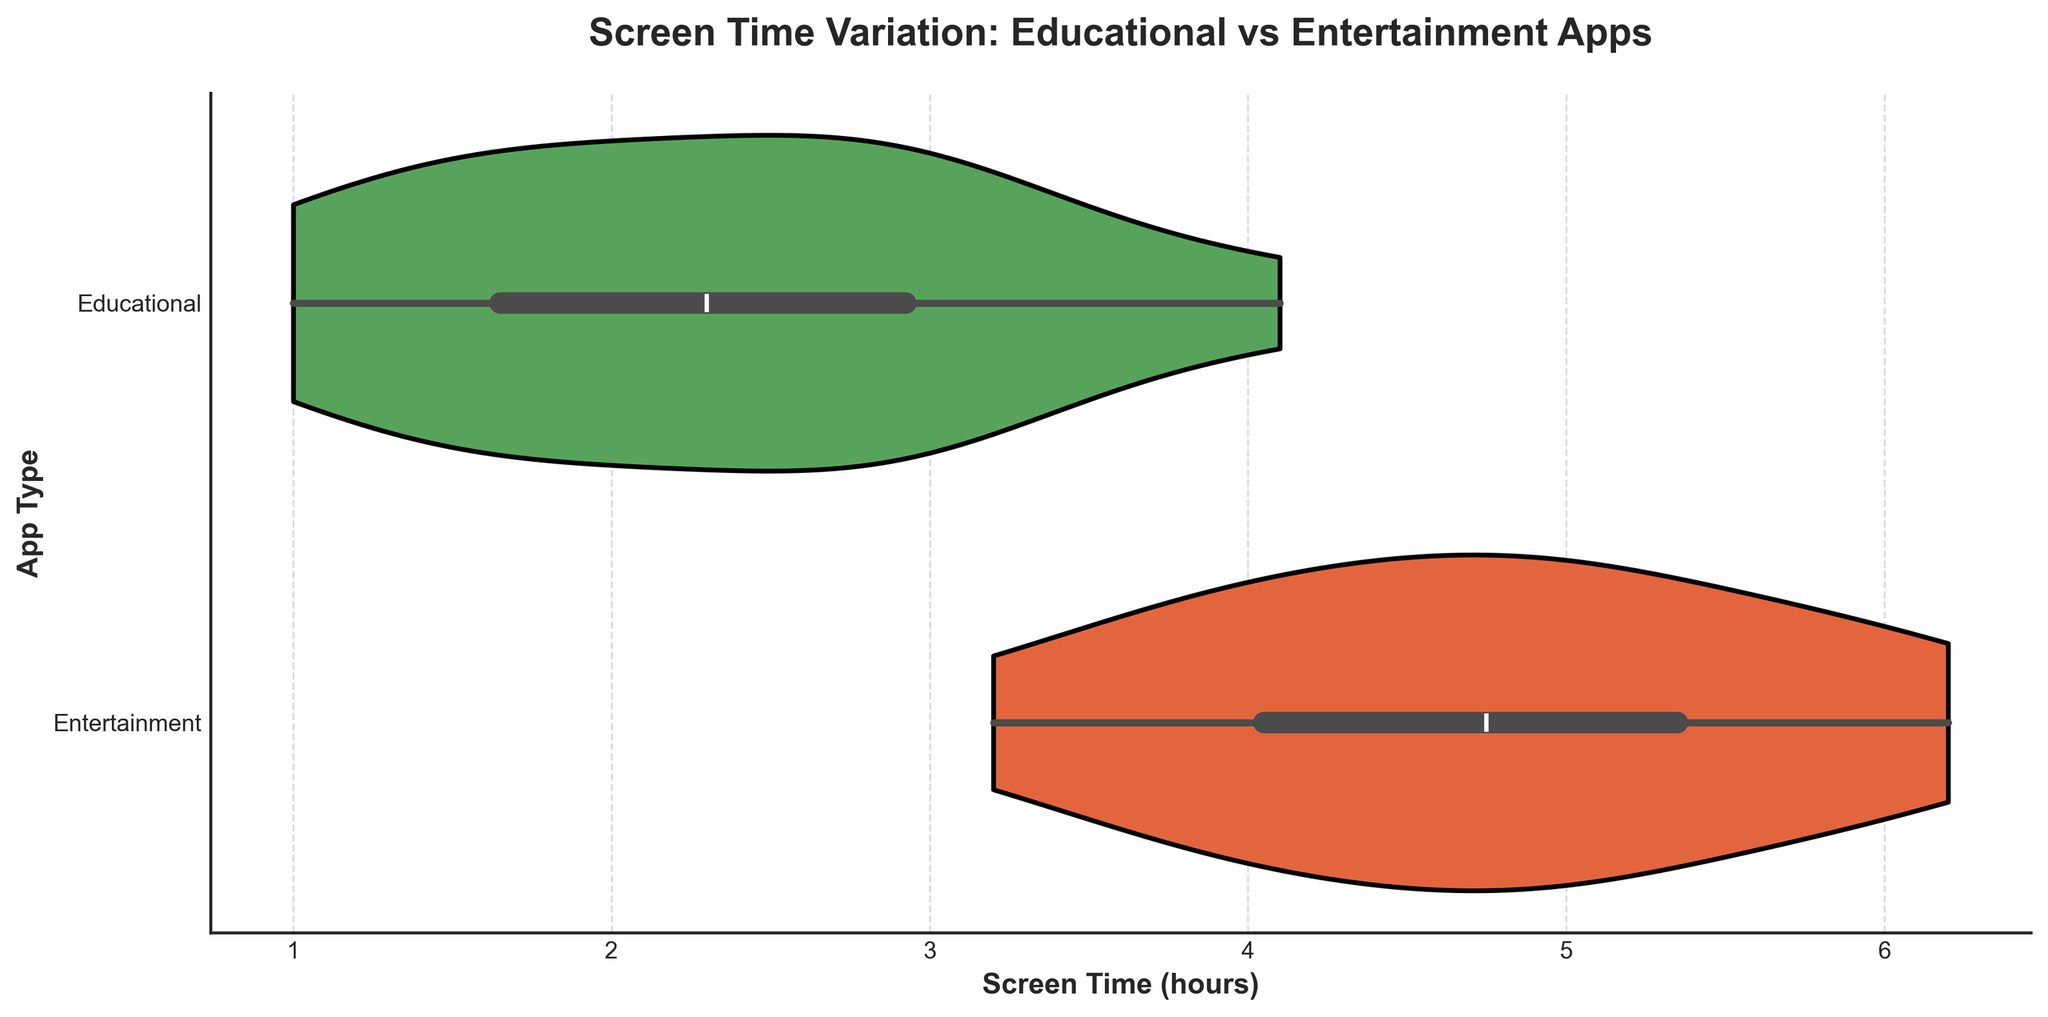What's the title of the chart? The title of the chart is displayed at the top and typically summarizes the key insight of the visualization in a few words. Here, it says "Screen Time Variation: Educational vs Entertainment Apps."
Answer: Screen Time Variation: Educational vs Entertainment Apps Which app type has a wider range of screen time? To determine the wider range of screen time, look at the spread of the violins. The entertainment apps' violin is more extended on both ends compared to educational apps.
Answer: Entertainment What is the average screen time for educational apps? Visualize the median line inside the violin for educational apps. The median is around 2.5 hours.
Answer: ~2.5 hours Which app type shows a higher peak in terms of density of screen time near the center? Examine the thickness or fullness of the violin near the median line. The educational apps have a higher density near the 2 to 2.5-hour mark.
Answer: Educational Is there a clear difference in the median screen time between the two app types? Compare the central white dots or lines of both violins. The median for entertainment apps is higher, around 5 hours compared to about 2.5 hours for educational apps.
Answer: Yes, the median for entertainment apps is higher What is the maximum screen time observed for educational apps? Look at the upper end of the educational violin plot. It extends to 4.1 hours.
Answer: 4.1 hours Are educational apps' screen times more uniformly distributed compared to entertainment apps? The violin for educational apps seems more evenly distributed, without any large peaks or dips, indicating a more uniform distribution. Entertainment apps have clear peaks and valleys showing more variance.
Answer: Yes What can be said about the variability in screen time usage for entertainment apps? The violin for entertainment apps is wider, indicating a greater variability in screen times. Screen times range from around 3.2 to 6.2 hours.
Answer: Greater variability By how many hours does the median screen time of entertainment apps exceed that of educational apps? The median for entertainment apps is around 5 hours, and for educational apps, it's around 2.5 hours. Subtract 2.5 from 5.
Answer: 2.5 hours Which app type's screen times are more likely to have outliers? Usually, the presence of dots outside the main violin can indicate outliers. There are no distant outliers seen in either, but entertainment apps show more spread which can edge towards outliers.
Answer: Entertainment 